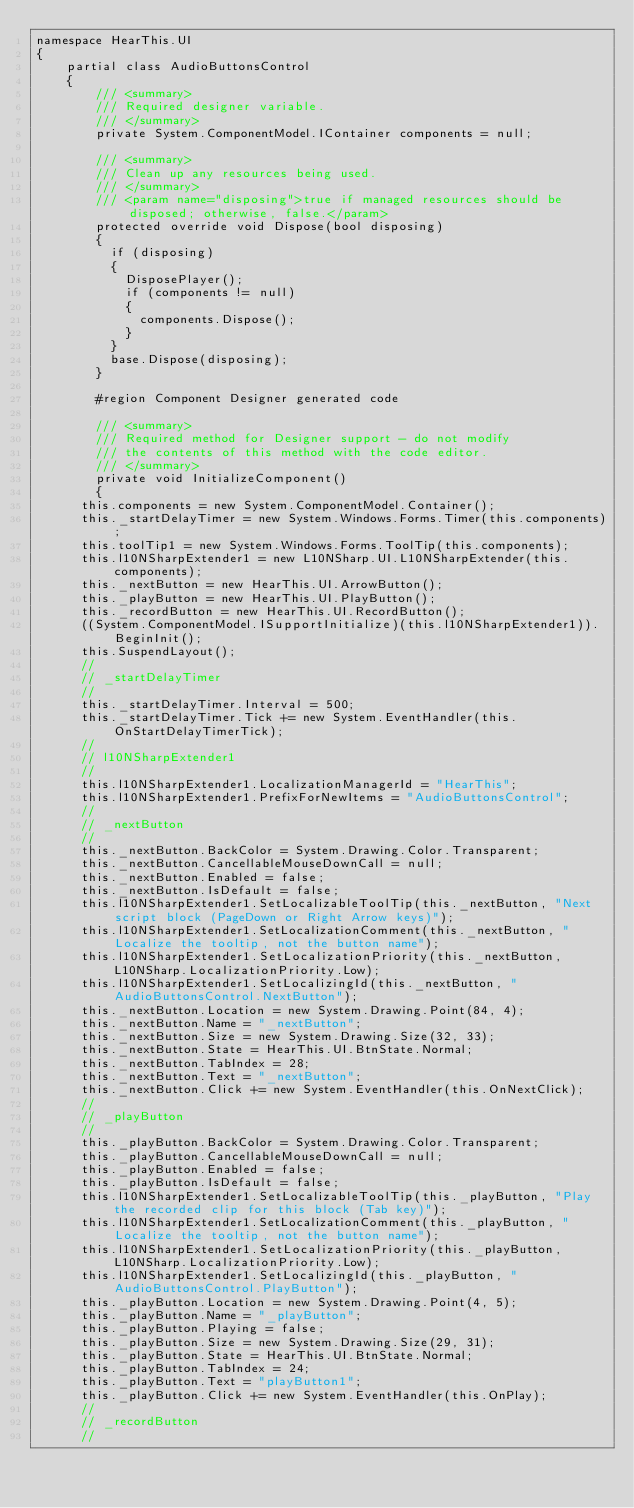<code> <loc_0><loc_0><loc_500><loc_500><_C#_>namespace HearThis.UI
{
    partial class AudioButtonsControl
    {
        /// <summary> 
        /// Required designer variable.
        /// </summary>
        private System.ComponentModel.IContainer components = null;

        /// <summary> 
        /// Clean up any resources being used.
        /// </summary>
        /// <param name="disposing">true if managed resources should be disposed; otherwise, false.</param>
        protected override void Dispose(bool disposing)
        {
	        if (disposing)
	        {
		        DisposePlayer();
		        if (components != null)
		        {
			        components.Dispose();
		        }
	        }
	        base.Dispose(disposing);
        }

        #region Component Designer generated code

        /// <summary> 
        /// Required method for Designer support - do not modify 
        /// the contents of this method with the code editor.
        /// </summary>
        private void InitializeComponent()
        {
			this.components = new System.ComponentModel.Container();
			this._startDelayTimer = new System.Windows.Forms.Timer(this.components);
			this.toolTip1 = new System.Windows.Forms.ToolTip(this.components);
			this.l10NSharpExtender1 = new L10NSharp.UI.L10NSharpExtender(this.components);
			this._nextButton = new HearThis.UI.ArrowButton();
			this._playButton = new HearThis.UI.PlayButton();
			this._recordButton = new HearThis.UI.RecordButton();
			((System.ComponentModel.ISupportInitialize)(this.l10NSharpExtender1)).BeginInit();
			this.SuspendLayout();
			// 
			// _startDelayTimer
			// 
			this._startDelayTimer.Interval = 500;
			this._startDelayTimer.Tick += new System.EventHandler(this.OnStartDelayTimerTick);
			// 
			// l10NSharpExtender1
			// 
			this.l10NSharpExtender1.LocalizationManagerId = "HearThis";
			this.l10NSharpExtender1.PrefixForNewItems = "AudioButtonsControl";
			// 
			// _nextButton
			// 
			this._nextButton.BackColor = System.Drawing.Color.Transparent;
			this._nextButton.CancellableMouseDownCall = null;
			this._nextButton.Enabled = false;
			this._nextButton.IsDefault = false;
			this.l10NSharpExtender1.SetLocalizableToolTip(this._nextButton, "Next script block (PageDown or Right Arrow keys)");
			this.l10NSharpExtender1.SetLocalizationComment(this._nextButton, "Localize the tooltip, not the button name");
			this.l10NSharpExtender1.SetLocalizationPriority(this._nextButton, L10NSharp.LocalizationPriority.Low);
			this.l10NSharpExtender1.SetLocalizingId(this._nextButton, "AudioButtonsControl.NextButton");
			this._nextButton.Location = new System.Drawing.Point(84, 4);
			this._nextButton.Name = "_nextButton";
			this._nextButton.Size = new System.Drawing.Size(32, 33);
			this._nextButton.State = HearThis.UI.BtnState.Normal;
			this._nextButton.TabIndex = 28;
			this._nextButton.Text = "_nextButton";
			this._nextButton.Click += new System.EventHandler(this.OnNextClick);
			// 
			// _playButton
			// 
			this._playButton.BackColor = System.Drawing.Color.Transparent;
			this._playButton.CancellableMouseDownCall = null;
			this._playButton.Enabled = false;
			this._playButton.IsDefault = false;
			this.l10NSharpExtender1.SetLocalizableToolTip(this._playButton, "Play the recorded clip for this block (Tab key)");
			this.l10NSharpExtender1.SetLocalizationComment(this._playButton, "Localize the tooltip, not the button name");
			this.l10NSharpExtender1.SetLocalizationPriority(this._playButton, L10NSharp.LocalizationPriority.Low);
			this.l10NSharpExtender1.SetLocalizingId(this._playButton, "AudioButtonsControl.PlayButton");
			this._playButton.Location = new System.Drawing.Point(4, 5);
			this._playButton.Name = "_playButton";
			this._playButton.Playing = false;
			this._playButton.Size = new System.Drawing.Size(29, 31);
			this._playButton.State = HearThis.UI.BtnState.Normal;
			this._playButton.TabIndex = 24;
			this._playButton.Text = "playButton1";
			this._playButton.Click += new System.EventHandler(this.OnPlay);
			// 
			// _recordButton
			// </code> 